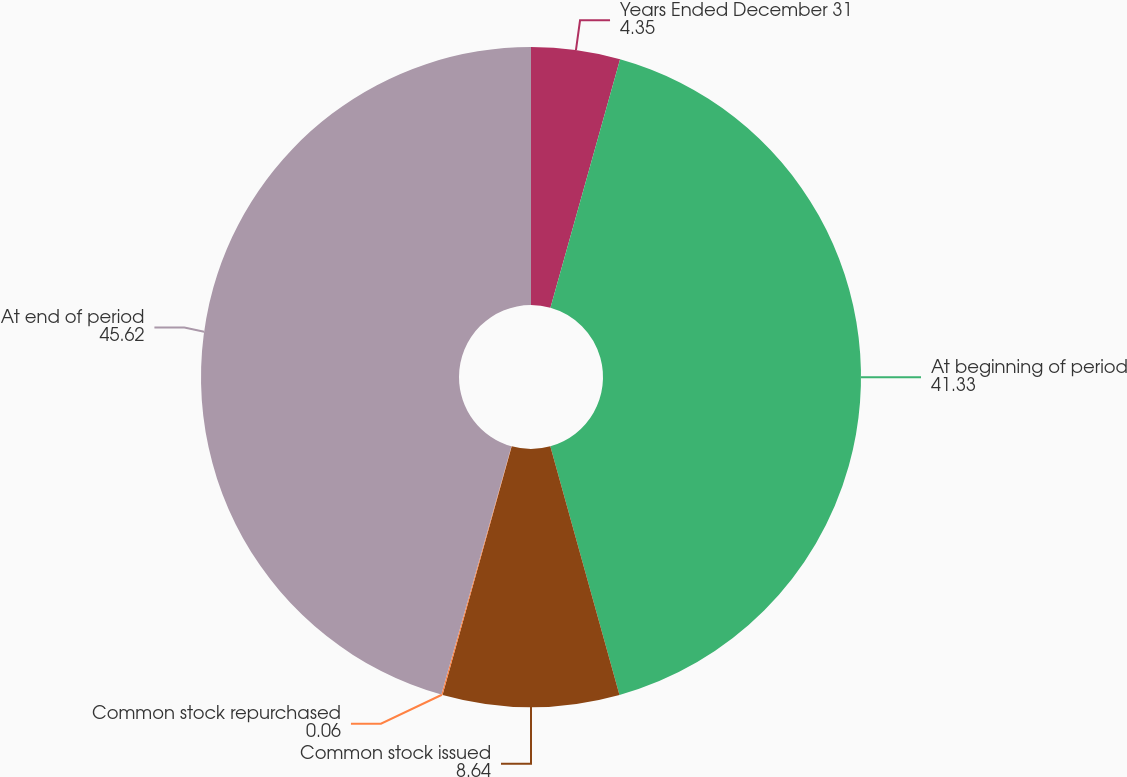Convert chart to OTSL. <chart><loc_0><loc_0><loc_500><loc_500><pie_chart><fcel>Years Ended December 31<fcel>At beginning of period<fcel>Common stock issued<fcel>Common stock repurchased<fcel>At end of period<nl><fcel>4.35%<fcel>41.33%<fcel>8.64%<fcel>0.06%<fcel>45.62%<nl></chart> 